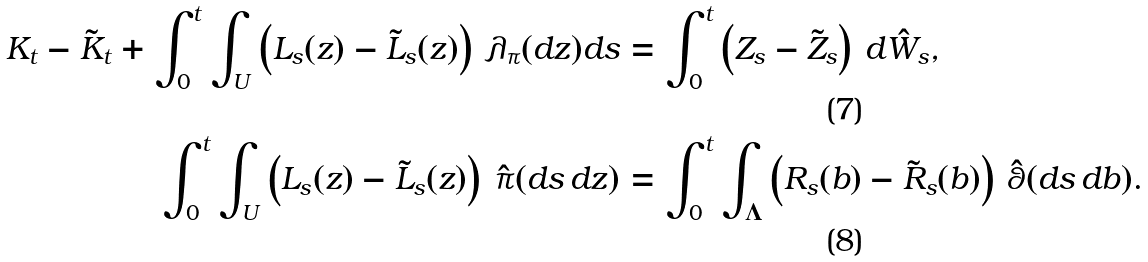Convert formula to latex. <formula><loc_0><loc_0><loc_500><loc_500>K _ { t } - \tilde { K } _ { t } + \int _ { 0 } ^ { t } \int _ { U } \left ( L _ { s } ( z ) - \tilde { L } _ { s } ( z ) \right ) \, \lambda _ { \pi } ( d z ) d s & = \int _ { 0 } ^ { t } \left ( Z _ { s } - \tilde { Z } _ { s } \right ) \, d \hat { W } _ { s } , \\ \int _ { 0 } ^ { t } \int _ { U } \left ( L _ { s } ( z ) - \tilde { L } _ { s } ( z ) \right ) \, \hat { \pi } ( d s \, d z ) & = \int _ { 0 } ^ { t } \int _ { \Lambda } \left ( R _ { s } ( b ) - \tilde { R } _ { s } ( b ) \right ) \, \hat { \theta } ( d s \, d b ) .</formula> 